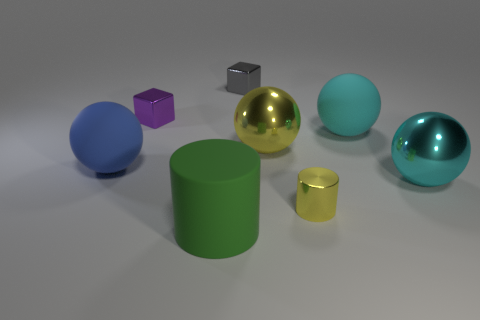Subtract all yellow spheres. How many spheres are left? 3 Add 1 tiny yellow rubber cylinders. How many objects exist? 9 Subtract all cylinders. How many objects are left? 6 Subtract 0 red balls. How many objects are left? 8 Subtract all large purple shiny blocks. Subtract all yellow objects. How many objects are left? 6 Add 5 yellow shiny balls. How many yellow shiny balls are left? 6 Add 5 tiny purple shiny objects. How many tiny purple shiny objects exist? 6 